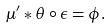<formula> <loc_0><loc_0><loc_500><loc_500>\mu ^ { \prime } * \theta \circ \epsilon = \phi .</formula> 